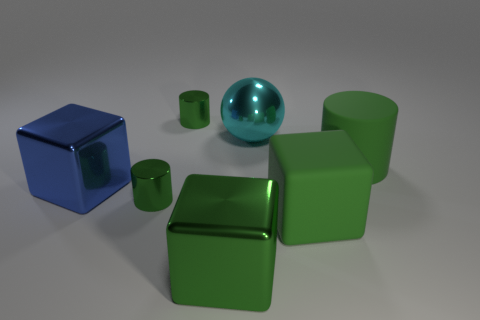Add 3 big green shiny blocks. How many objects exist? 10 Subtract 2 cylinders. How many cylinders are left? 1 Subtract all gray blocks. Subtract all purple spheres. How many blocks are left? 3 Subtract all purple spheres. How many cyan blocks are left? 0 Subtract all large blocks. Subtract all big cyan balls. How many objects are left? 3 Add 7 tiny green shiny things. How many tiny green shiny things are left? 9 Add 5 large cylinders. How many large cylinders exist? 6 Subtract all blue blocks. How many blocks are left? 2 Subtract all big green rubber cylinders. How many cylinders are left? 2 Subtract 0 red blocks. How many objects are left? 7 